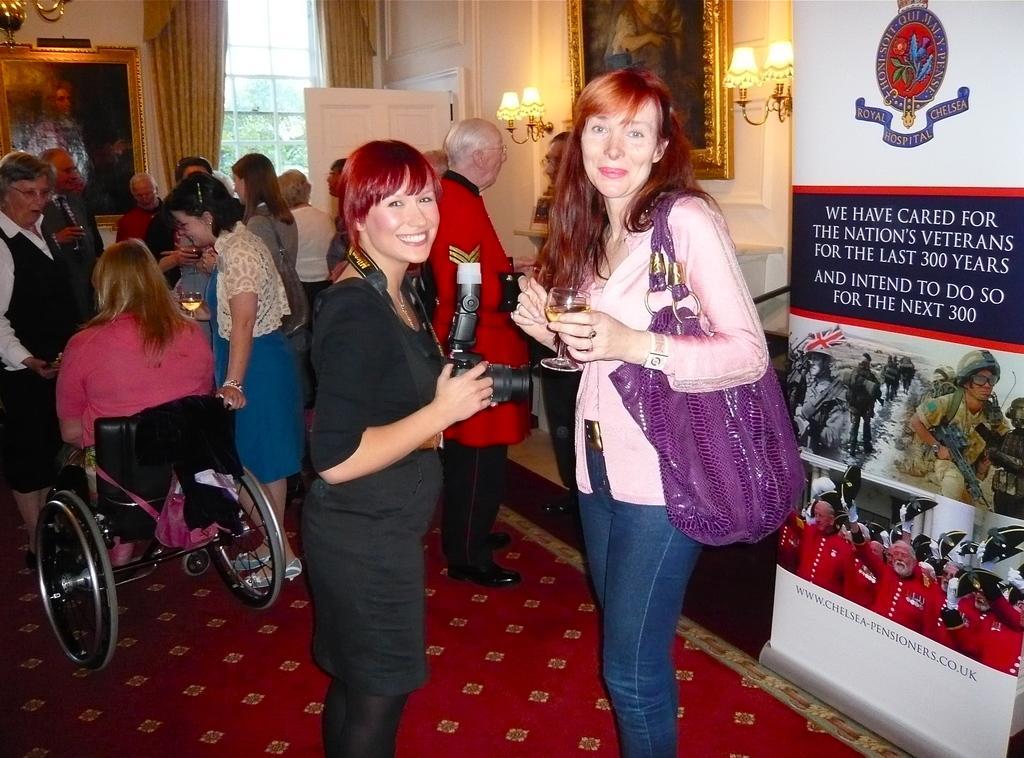How would you summarize this image in a sentence or two? This picture is taken inside the room. In this image, in the middle, we can see two women, one woman is wearing a hand bag and holding a wine glass in her hand and other woman is wearing a black color dress and holding a camera in her hand. On the right side, we can see a hoarding. In the background, we can see a group people. On the left side, we can see a woman sitting on the wheelchair. In the background, we can see a door, curtains, glass window and a photo frame which is attached to a wall. On the right side, we can also see another photo frame which is attached to wall, few lights. At the bottom, we can see a red color carpet. 